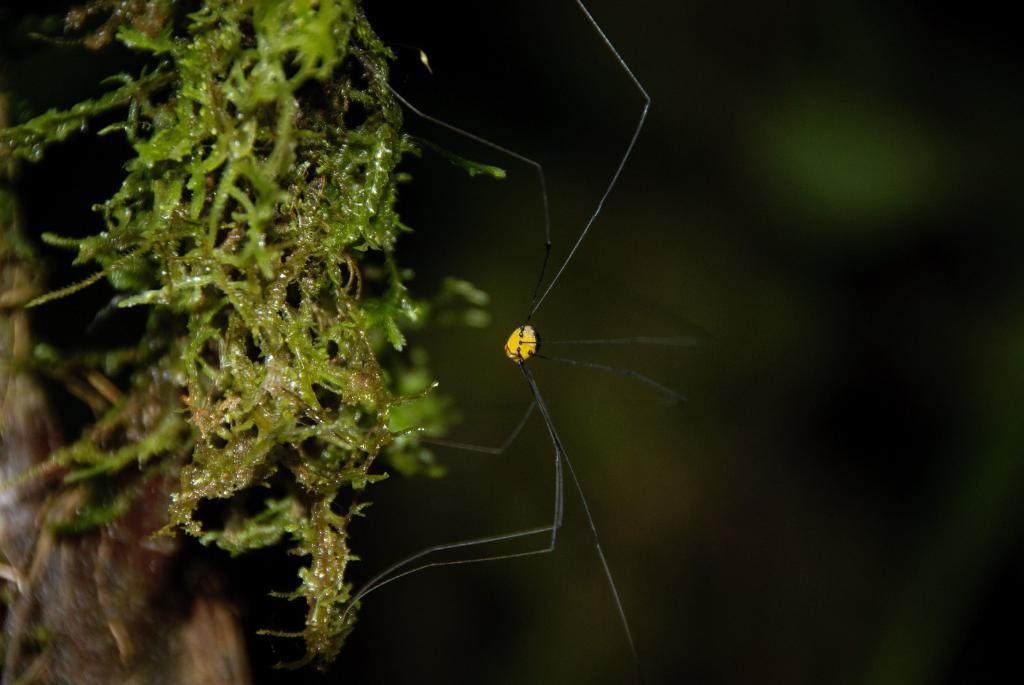Where was the image taken? The image was taken outdoors. What can be seen on the left side of the image? There is a tree on the left side of the image. What is the main subject in the middle of the image? There is a spider in the middle of the image. What type of form does the aunt fill out on the dock in the image? There is no aunt or dock present in the image; it features a tree and a spider. 